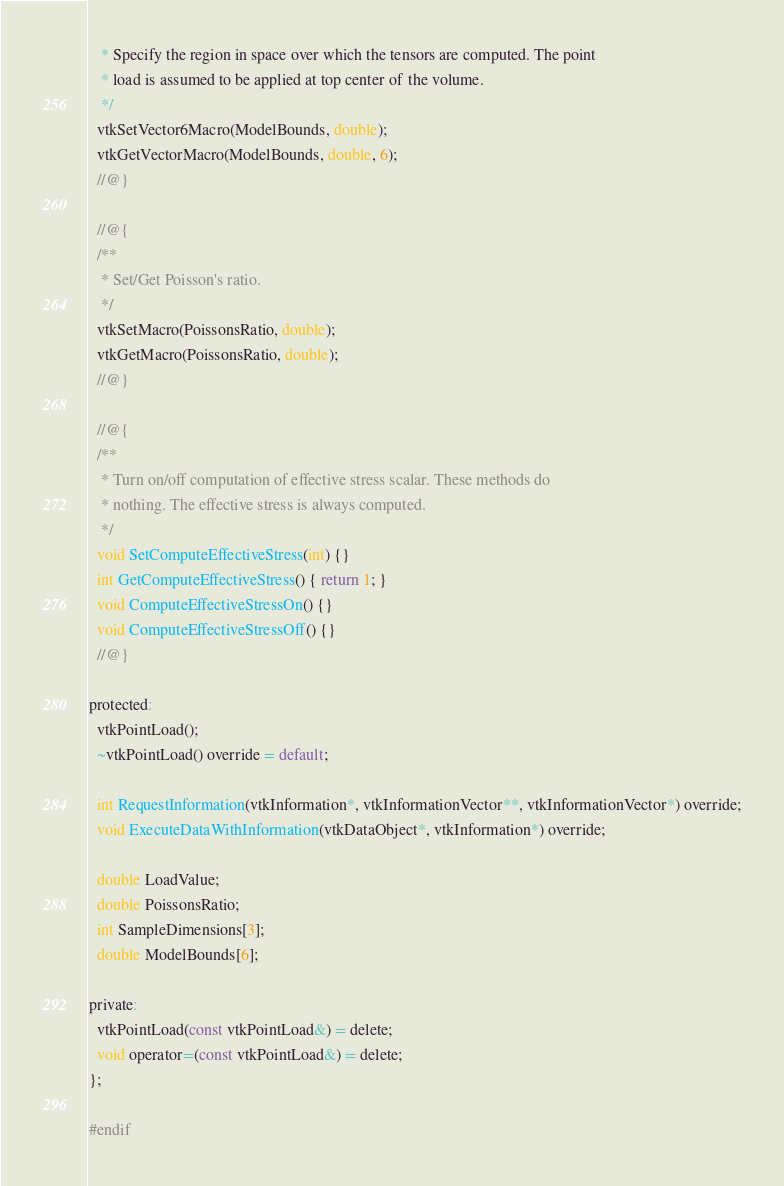<code> <loc_0><loc_0><loc_500><loc_500><_C_>   * Specify the region in space over which the tensors are computed. The point
   * load is assumed to be applied at top center of the volume.
   */
  vtkSetVector6Macro(ModelBounds, double);
  vtkGetVectorMacro(ModelBounds, double, 6);
  //@}

  //@{
  /**
   * Set/Get Poisson's ratio.
   */
  vtkSetMacro(PoissonsRatio, double);
  vtkGetMacro(PoissonsRatio, double);
  //@}

  //@{
  /**
   * Turn on/off computation of effective stress scalar. These methods do
   * nothing. The effective stress is always computed.
   */
  void SetComputeEffectiveStress(int) {}
  int GetComputeEffectiveStress() { return 1; }
  void ComputeEffectiveStressOn() {}
  void ComputeEffectiveStressOff() {}
  //@}

protected:
  vtkPointLoad();
  ~vtkPointLoad() override = default;

  int RequestInformation(vtkInformation*, vtkInformationVector**, vtkInformationVector*) override;
  void ExecuteDataWithInformation(vtkDataObject*, vtkInformation*) override;

  double LoadValue;
  double PoissonsRatio;
  int SampleDimensions[3];
  double ModelBounds[6];

private:
  vtkPointLoad(const vtkPointLoad&) = delete;
  void operator=(const vtkPointLoad&) = delete;
};

#endif
</code> 